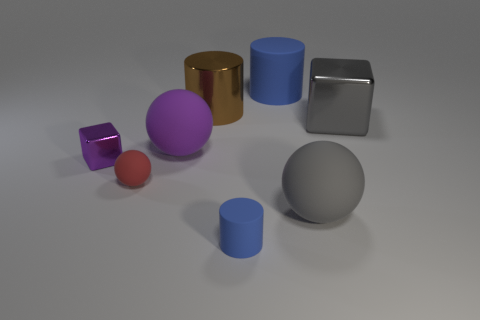Is the color of the metal block that is on the right side of the large gray rubber ball the same as the tiny sphere?
Offer a very short reply. No. What number of blue matte cylinders are behind the large brown shiny cylinder and in front of the big purple thing?
Your response must be concise. 0. The gray object that is the same shape as the red object is what size?
Provide a short and direct response. Large. What number of small red balls are in front of the blue matte cylinder in front of the big cylinder behind the brown thing?
Provide a short and direct response. 0. The large metal cylinder on the left side of the big metal thing that is in front of the brown cylinder is what color?
Your answer should be very brief. Brown. What number of other objects are there of the same material as the large gray block?
Give a very brief answer. 2. What number of large metallic objects are behind the big sphere that is on the right side of the brown metal cylinder?
Make the answer very short. 2. Is there any other thing that is the same shape as the purple metallic thing?
Your response must be concise. Yes. Do the big matte ball that is in front of the small shiny object and the cylinder that is in front of the brown metallic object have the same color?
Keep it short and to the point. No. Is the number of purple cubes less than the number of purple rubber cubes?
Ensure brevity in your answer.  No. 